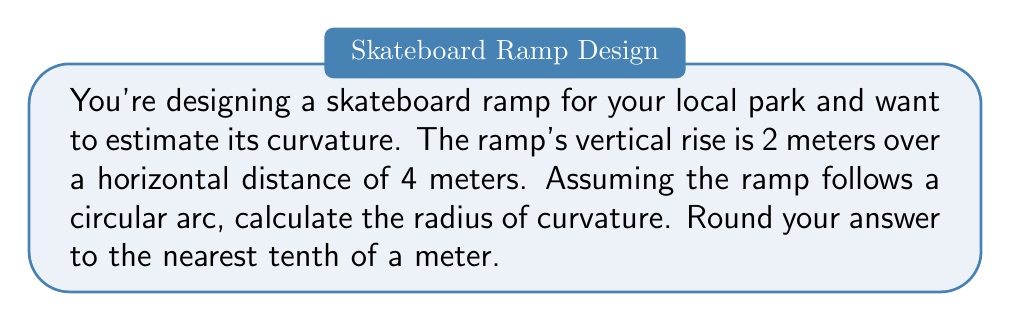Show me your answer to this math problem. Let's approach this step-by-step:

1) The ramp forms a circular segment. We need to find the radius of the circle it's part of.

2) Let's visualize the problem:

[asy]
unitsize(30);
pair A = (0,0), B = (4,0), C = (4,2), O = (0,4);
draw(A--B--C--cycle);
draw(Arc(O,4,0,90));
label("A",A,SW);
label("B",B,SE);
label("C",C,NE);
label("O",O,NW);
label("2m",C--B,E);
label("4m",A--B,S);
label("r",O--B,NE);
[/asy]

3) In this diagram, O is the center of the circle, and r is the radius we're looking for.

4) We can use the Pythagorean theorem in the right triangle OAB:

   $$r^2 = (r-2)^2 + 4^2$$

5) Expand this equation:

   $$r^2 = r^2 - 4r + 4 + 16$$

6) Simplify:

   $$r^2 = r^2 - 4r + 20$$

7) Subtract $r^2$ from both sides:

   $$0 = -4r + 20$$

8) Add 4r to both sides:

   $$4r = 20$$

9) Divide both sides by 4:

   $$r = 5$$

10) Therefore, the radius of curvature is 5 meters.
Answer: $5.0$ m 